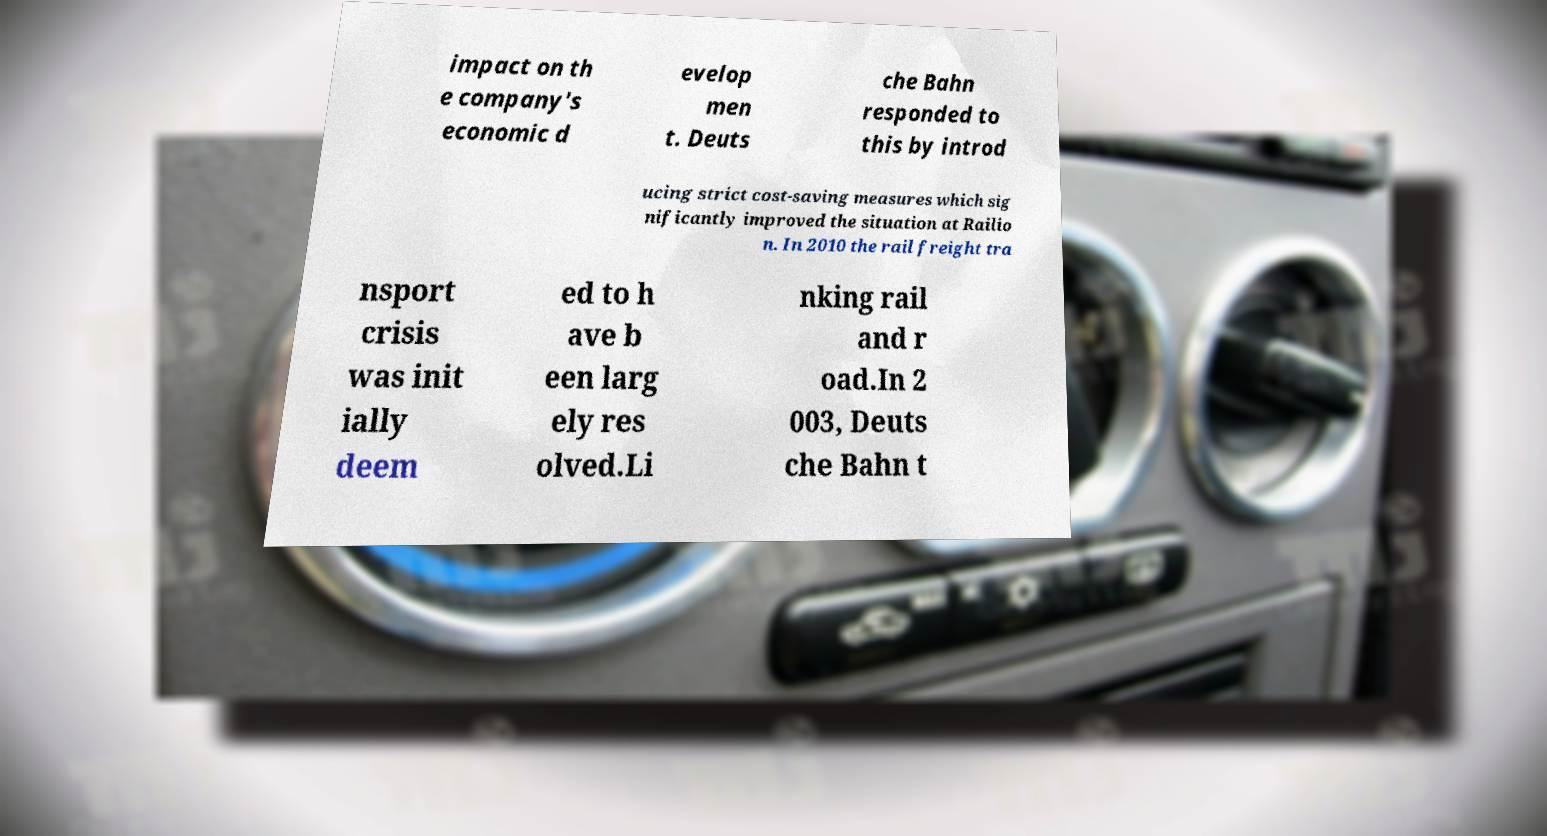Please identify and transcribe the text found in this image. impact on th e company's economic d evelop men t. Deuts che Bahn responded to this by introd ucing strict cost-saving measures which sig nificantly improved the situation at Railio n. In 2010 the rail freight tra nsport crisis was init ially deem ed to h ave b een larg ely res olved.Li nking rail and r oad.In 2 003, Deuts che Bahn t 